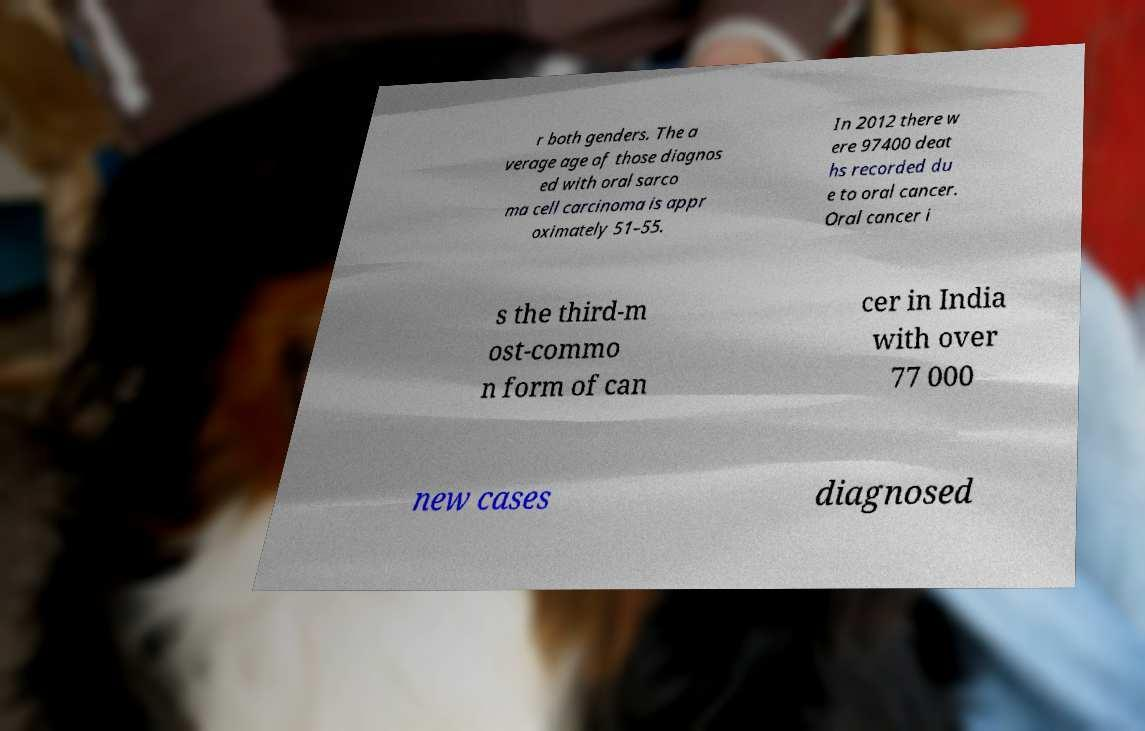Could you extract and type out the text from this image? r both genders. The a verage age of those diagnos ed with oral sarco ma cell carcinoma is appr oximately 51–55. In 2012 there w ere 97400 deat hs recorded du e to oral cancer. Oral cancer i s the third-m ost-commo n form of can cer in India with over 77 000 new cases diagnosed 